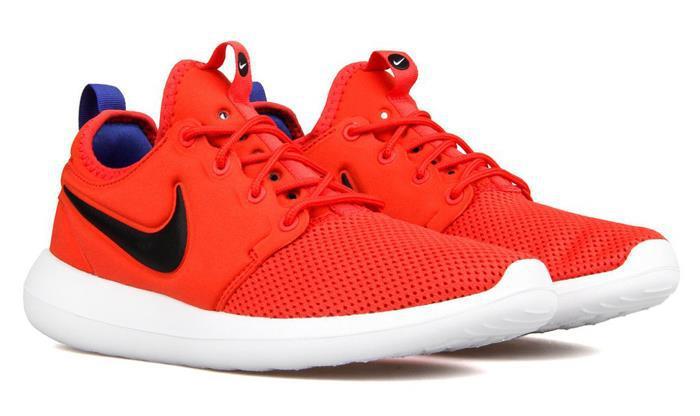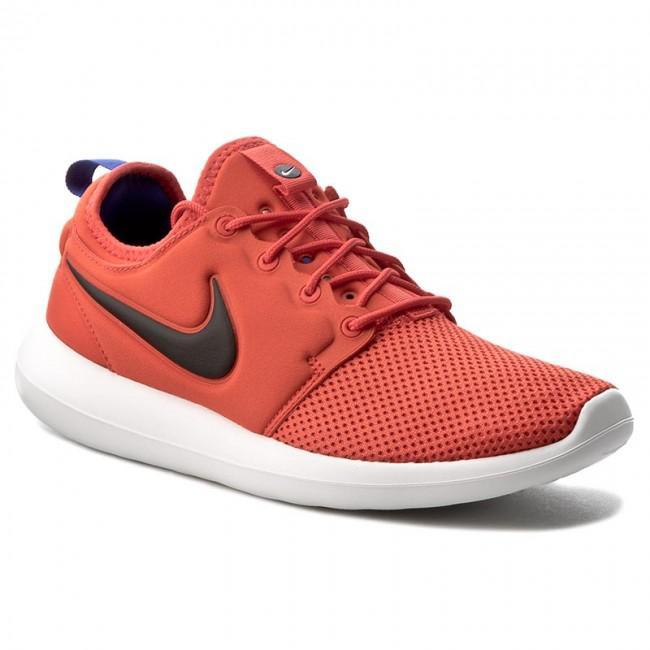The first image is the image on the left, the second image is the image on the right. Evaluate the accuracy of this statement regarding the images: "Left image shows a pair of orange sneakers, and right image shows just one sneaker.". Is it true? Answer yes or no. Yes. The first image is the image on the left, the second image is the image on the right. For the images displayed, is the sentence "The pair of shoes is on the left of the single shoe." factually correct? Answer yes or no. Yes. 